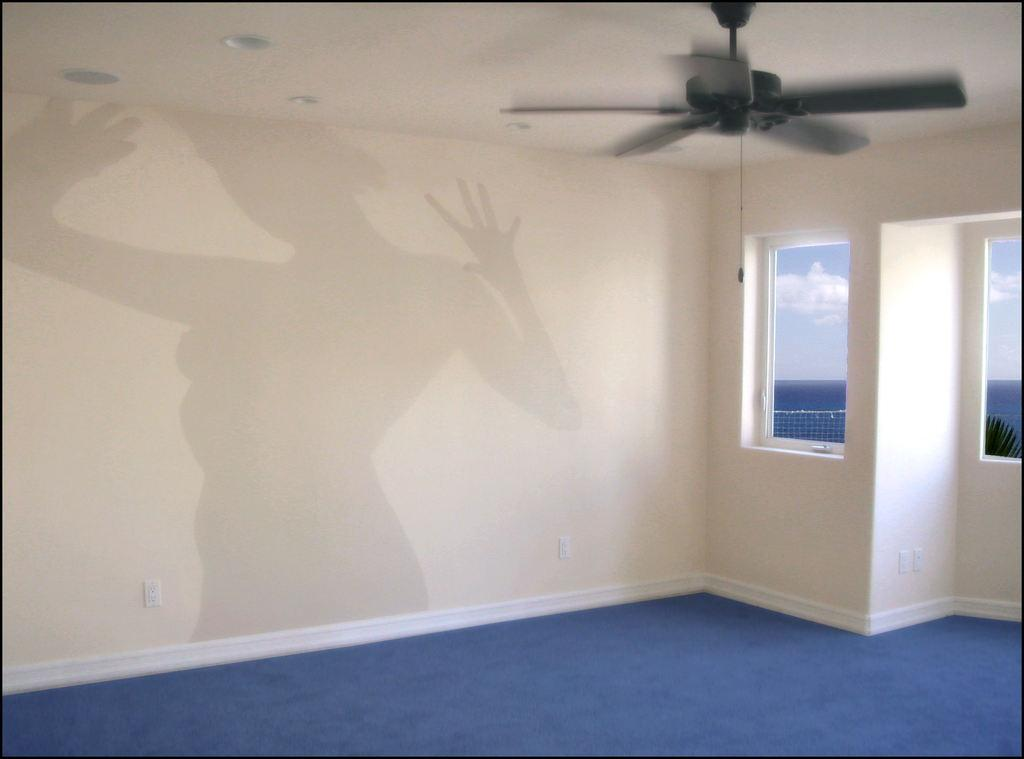What can be seen on the wall in the image? There is a shadow on the wall in the image. Where are the windows located in the image? The windows are on the right side of the image. What is present in the top right of the image? There is a ceiling fan in the top right of the image. What type of cloud is visible through the windows in the image? There is no cloud visible through the windows in the image; the windows are not transparent. What substance is being coached in the image? There is no coach or substance being coached present in the image. 